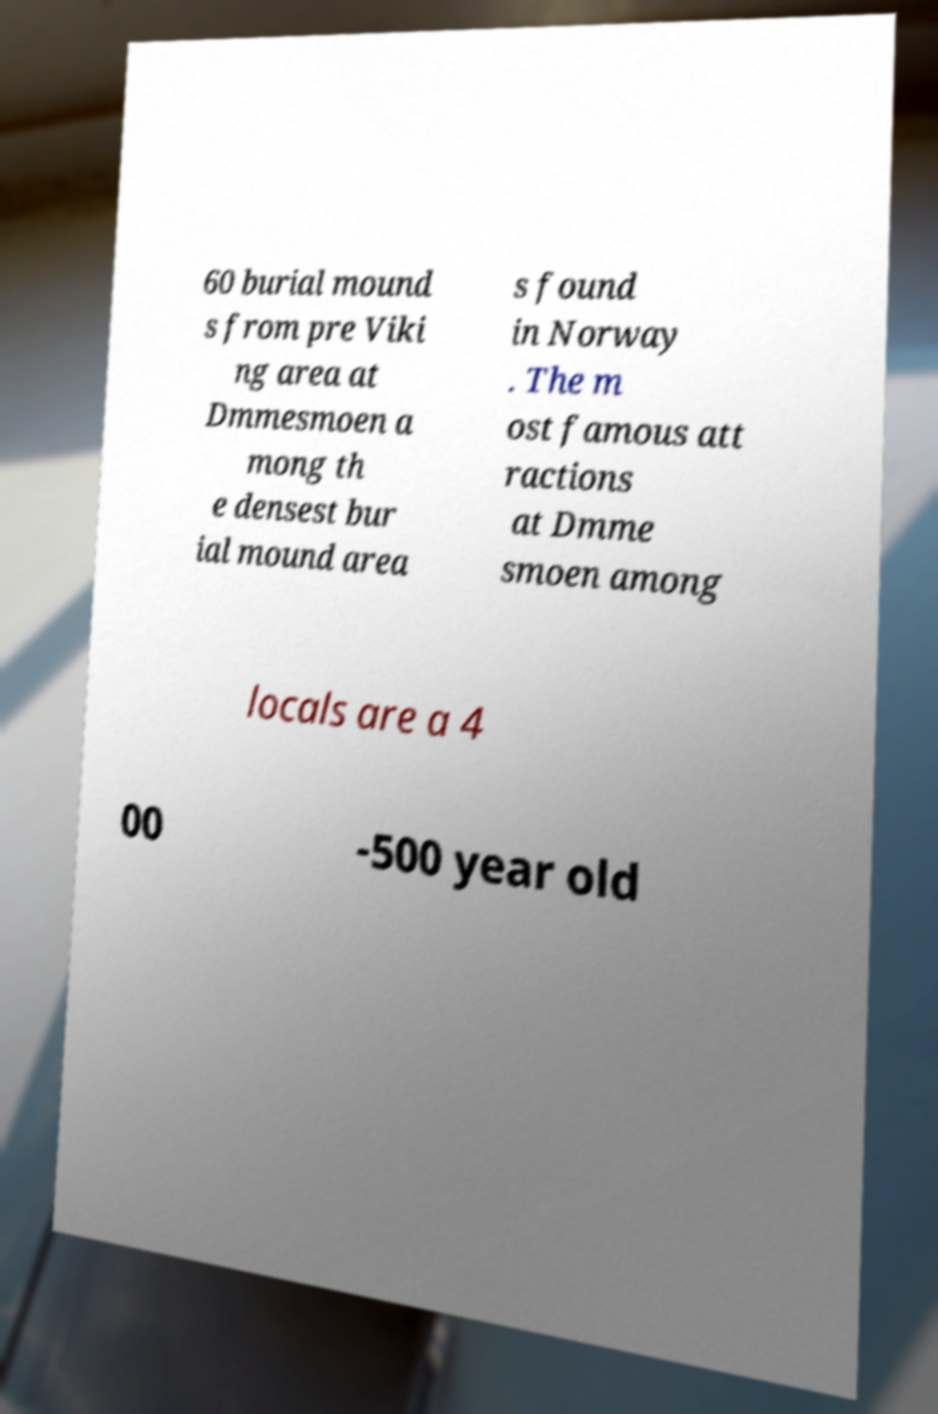Can you read and provide the text displayed in the image?This photo seems to have some interesting text. Can you extract and type it out for me? 60 burial mound s from pre Viki ng area at Dmmesmoen a mong th e densest bur ial mound area s found in Norway . The m ost famous att ractions at Dmme smoen among locals are a 4 00 -500 year old 